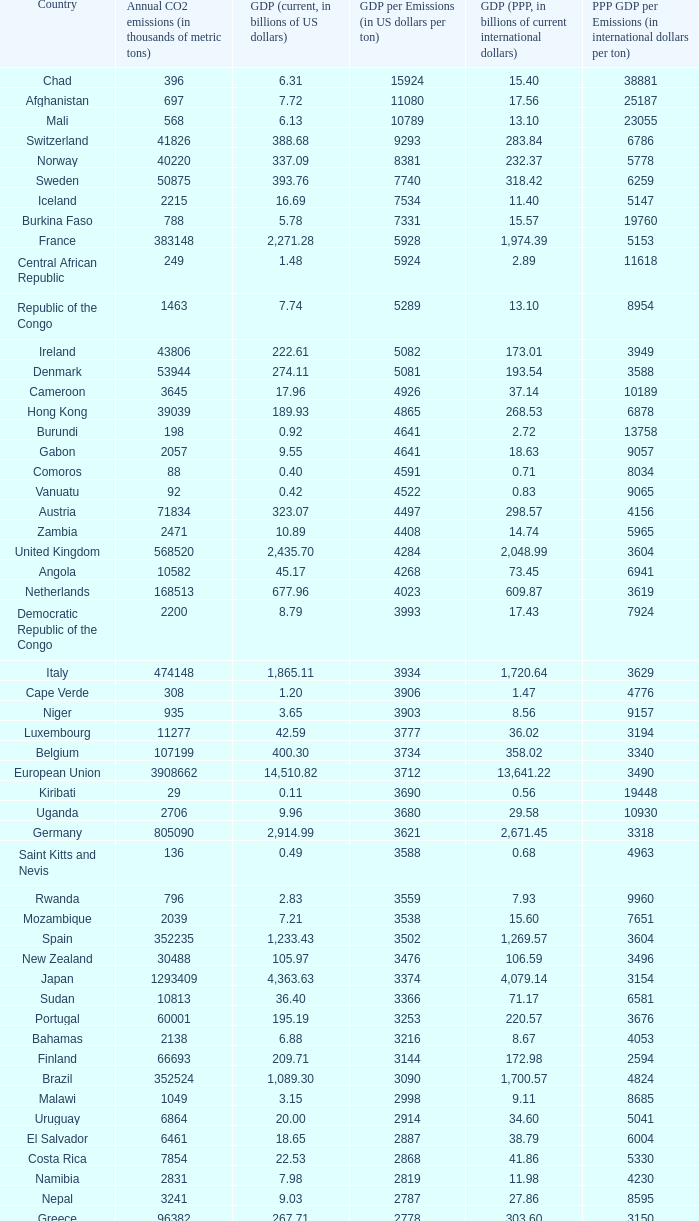93, what is the peak ppp gdp per emissions (in global dollars per ton)? 9960.0. 